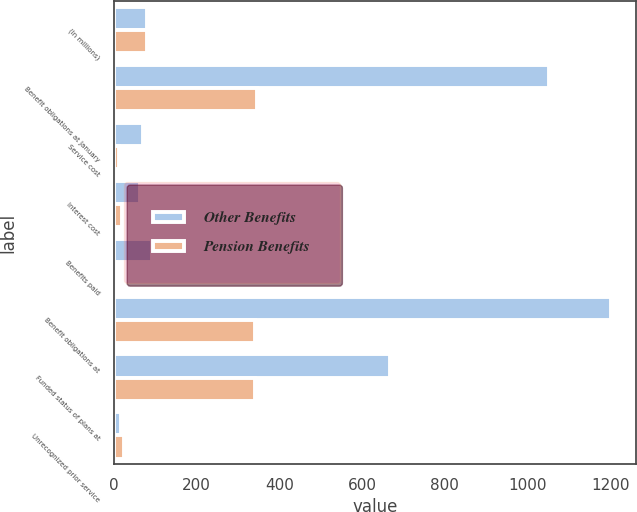Convert chart. <chart><loc_0><loc_0><loc_500><loc_500><stacked_bar_chart><ecel><fcel>(In millions)<fcel>Benefit obligations at January<fcel>Service cost<fcel>Interest cost<fcel>Benefits paid<fcel>Benefit obligations at<fcel>Funded status of plans at<fcel>Unrecognized prior service<nl><fcel>Other Benefits<fcel>81<fcel>1051<fcel>70<fcel>64<fcel>92<fcel>1203<fcel>668<fcel>18<nl><fcel>Pension Benefits<fcel>81<fcel>346<fcel>14<fcel>20<fcel>5<fcel>341<fcel>341<fcel>26<nl></chart> 